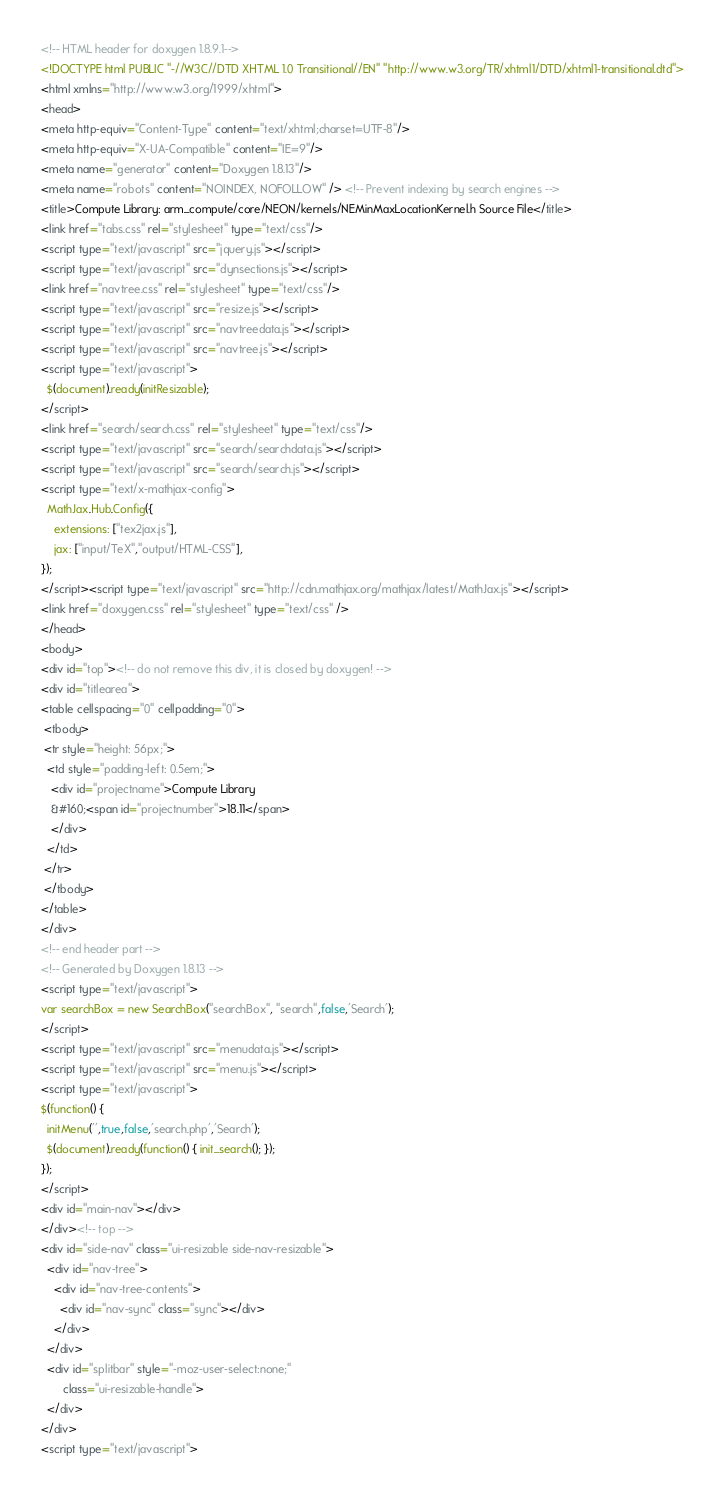<code> <loc_0><loc_0><loc_500><loc_500><_HTML_><!-- HTML header for doxygen 1.8.9.1-->
<!DOCTYPE html PUBLIC "-//W3C//DTD XHTML 1.0 Transitional//EN" "http://www.w3.org/TR/xhtml1/DTD/xhtml1-transitional.dtd">
<html xmlns="http://www.w3.org/1999/xhtml">
<head>
<meta http-equiv="Content-Type" content="text/xhtml;charset=UTF-8"/>
<meta http-equiv="X-UA-Compatible" content="IE=9"/>
<meta name="generator" content="Doxygen 1.8.13"/>
<meta name="robots" content="NOINDEX, NOFOLLOW" /> <!-- Prevent indexing by search engines -->
<title>Compute Library: arm_compute/core/NEON/kernels/NEMinMaxLocationKernel.h Source File</title>
<link href="tabs.css" rel="stylesheet" type="text/css"/>
<script type="text/javascript" src="jquery.js"></script>
<script type="text/javascript" src="dynsections.js"></script>
<link href="navtree.css" rel="stylesheet" type="text/css"/>
<script type="text/javascript" src="resize.js"></script>
<script type="text/javascript" src="navtreedata.js"></script>
<script type="text/javascript" src="navtree.js"></script>
<script type="text/javascript">
  $(document).ready(initResizable);
</script>
<link href="search/search.css" rel="stylesheet" type="text/css"/>
<script type="text/javascript" src="search/searchdata.js"></script>
<script type="text/javascript" src="search/search.js"></script>
<script type="text/x-mathjax-config">
  MathJax.Hub.Config({
    extensions: ["tex2jax.js"],
    jax: ["input/TeX","output/HTML-CSS"],
});
</script><script type="text/javascript" src="http://cdn.mathjax.org/mathjax/latest/MathJax.js"></script>
<link href="doxygen.css" rel="stylesheet" type="text/css" />
</head>
<body>
<div id="top"><!-- do not remove this div, it is closed by doxygen! -->
<div id="titlearea">
<table cellspacing="0" cellpadding="0">
 <tbody>
 <tr style="height: 56px;">
  <td style="padding-left: 0.5em;">
   <div id="projectname">Compute Library
   &#160;<span id="projectnumber">18.11</span>
   </div>
  </td>
 </tr>
 </tbody>
</table>
</div>
<!-- end header part -->
<!-- Generated by Doxygen 1.8.13 -->
<script type="text/javascript">
var searchBox = new SearchBox("searchBox", "search",false,'Search');
</script>
<script type="text/javascript" src="menudata.js"></script>
<script type="text/javascript" src="menu.js"></script>
<script type="text/javascript">
$(function() {
  initMenu('',true,false,'search.php','Search');
  $(document).ready(function() { init_search(); });
});
</script>
<div id="main-nav"></div>
</div><!-- top -->
<div id="side-nav" class="ui-resizable side-nav-resizable">
  <div id="nav-tree">
    <div id="nav-tree-contents">
      <div id="nav-sync" class="sync"></div>
    </div>
  </div>
  <div id="splitbar" style="-moz-user-select:none;" 
       class="ui-resizable-handle">
  </div>
</div>
<script type="text/javascript"></code> 